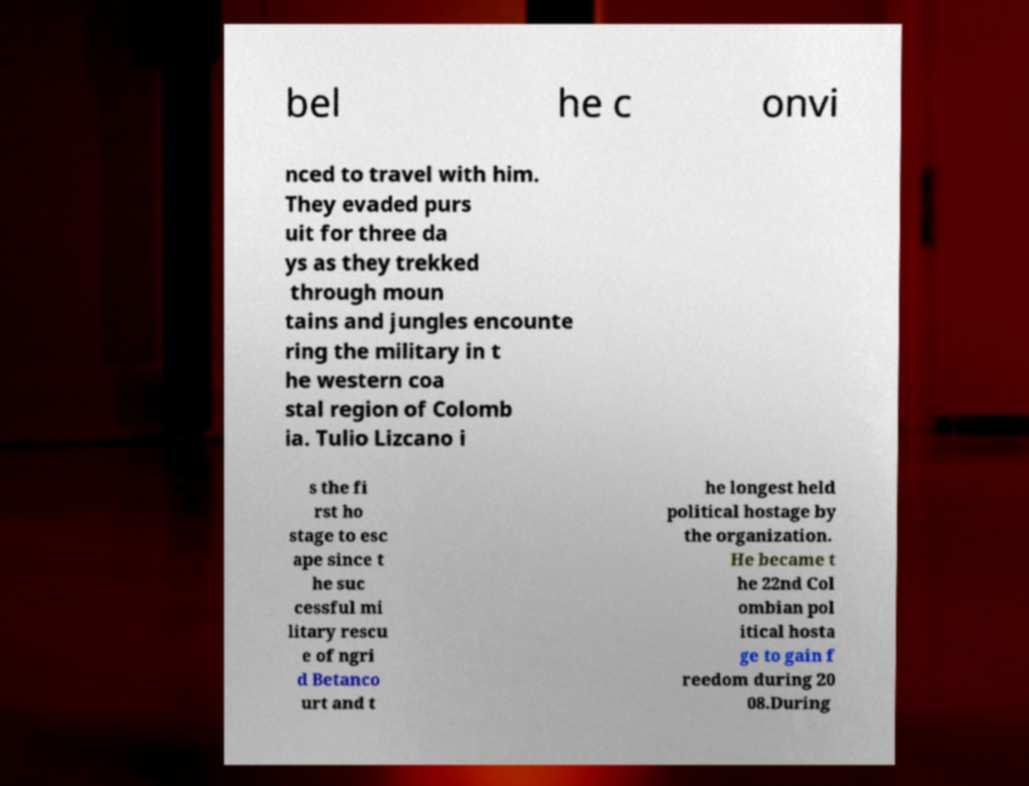Can you accurately transcribe the text from the provided image for me? bel he c onvi nced to travel with him. They evaded purs uit for three da ys as they trekked through moun tains and jungles encounte ring the military in t he western coa stal region of Colomb ia. Tulio Lizcano i s the fi rst ho stage to esc ape since t he suc cessful mi litary rescu e of ngri d Betanco urt and t he longest held political hostage by the organization. He became t he 22nd Col ombian pol itical hosta ge to gain f reedom during 20 08.During 